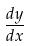Convert formula to latex. <formula><loc_0><loc_0><loc_500><loc_500>\frac { d y } { d x }</formula> 